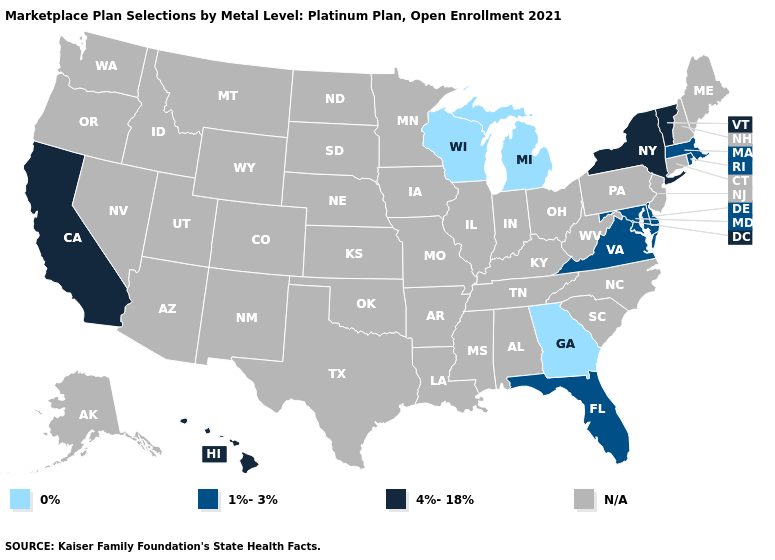Name the states that have a value in the range N/A?
Short answer required. Alabama, Alaska, Arizona, Arkansas, Colorado, Connecticut, Idaho, Illinois, Indiana, Iowa, Kansas, Kentucky, Louisiana, Maine, Minnesota, Mississippi, Missouri, Montana, Nebraska, Nevada, New Hampshire, New Jersey, New Mexico, North Carolina, North Dakota, Ohio, Oklahoma, Oregon, Pennsylvania, South Carolina, South Dakota, Tennessee, Texas, Utah, Washington, West Virginia, Wyoming. What is the value of New York?
Keep it brief. 4%-18%. What is the value of California?
Short answer required. 4%-18%. Name the states that have a value in the range N/A?
Give a very brief answer. Alabama, Alaska, Arizona, Arkansas, Colorado, Connecticut, Idaho, Illinois, Indiana, Iowa, Kansas, Kentucky, Louisiana, Maine, Minnesota, Mississippi, Missouri, Montana, Nebraska, Nevada, New Hampshire, New Jersey, New Mexico, North Carolina, North Dakota, Ohio, Oklahoma, Oregon, Pennsylvania, South Carolina, South Dakota, Tennessee, Texas, Utah, Washington, West Virginia, Wyoming. Name the states that have a value in the range N/A?
Keep it brief. Alabama, Alaska, Arizona, Arkansas, Colorado, Connecticut, Idaho, Illinois, Indiana, Iowa, Kansas, Kentucky, Louisiana, Maine, Minnesota, Mississippi, Missouri, Montana, Nebraska, Nevada, New Hampshire, New Jersey, New Mexico, North Carolina, North Dakota, Ohio, Oklahoma, Oregon, Pennsylvania, South Carolina, South Dakota, Tennessee, Texas, Utah, Washington, West Virginia, Wyoming. What is the highest value in the MidWest ?
Give a very brief answer. 0%. Which states have the lowest value in the USA?
Give a very brief answer. Georgia, Michigan, Wisconsin. Which states have the lowest value in the MidWest?
Give a very brief answer. Michigan, Wisconsin. Name the states that have a value in the range 0%?
Keep it brief. Georgia, Michigan, Wisconsin. What is the value of Virginia?
Concise answer only. 1%-3%. 